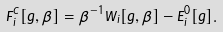<formula> <loc_0><loc_0><loc_500><loc_500>F _ { i } ^ { C } [ g , \beta ] = \beta ^ { - 1 } \bar { W } _ { i } [ g , \beta ] - \bar { E } _ { i } ^ { 0 } [ g ] .</formula> 